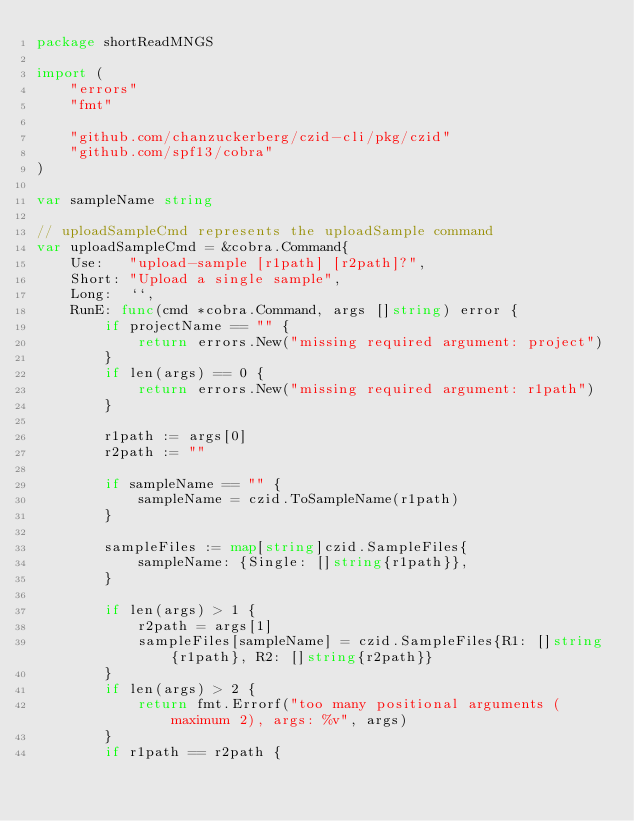<code> <loc_0><loc_0><loc_500><loc_500><_Go_>package shortReadMNGS

import (
	"errors"
	"fmt"

	"github.com/chanzuckerberg/czid-cli/pkg/czid"
	"github.com/spf13/cobra"
)

var sampleName string

// uploadSampleCmd represents the uploadSample command
var uploadSampleCmd = &cobra.Command{
	Use:   "upload-sample [r1path] [r2path]?",
	Short: "Upload a single sample",
	Long:  ``,
	RunE: func(cmd *cobra.Command, args []string) error {
		if projectName == "" {
			return errors.New("missing required argument: project")
		}
		if len(args) == 0 {
			return errors.New("missing required argument: r1path")
		}

		r1path := args[0]
		r2path := ""

		if sampleName == "" {
			sampleName = czid.ToSampleName(r1path)
		}

		sampleFiles := map[string]czid.SampleFiles{
			sampleName: {Single: []string{r1path}},
		}

		if len(args) > 1 {
			r2path = args[1]
			sampleFiles[sampleName] = czid.SampleFiles{R1: []string{r1path}, R2: []string{r2path}}
		}
		if len(args) > 2 {
			return fmt.Errorf("too many positional arguments (maximum 2), args: %v", args)
		}
		if r1path == r2path {</code> 